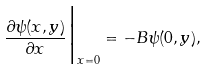Convert formula to latex. <formula><loc_0><loc_0><loc_500><loc_500>\frac { \partial \psi ( x , y ) } { \partial x } \Big | _ { x = 0 } = - B \psi ( 0 , y ) ,</formula> 